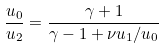Convert formula to latex. <formula><loc_0><loc_0><loc_500><loc_500>\frac { u _ { 0 } } { u _ { 2 } } = \frac { \gamma + 1 } { \gamma - 1 + \nu u _ { 1 } / u _ { 0 } }</formula> 